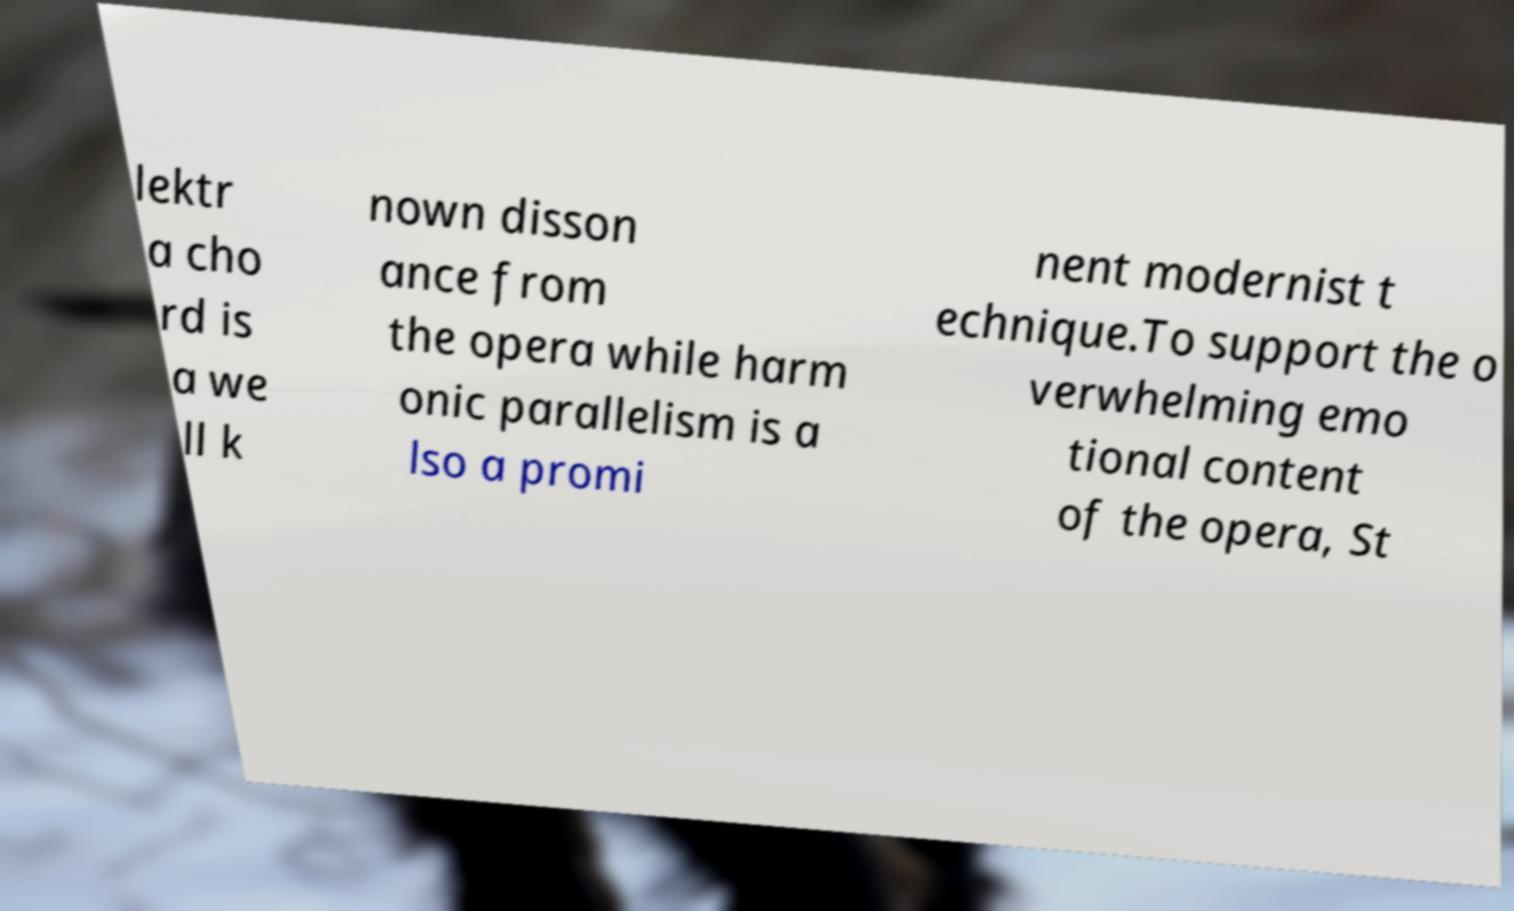Could you extract and type out the text from this image? lektr a cho rd is a we ll k nown disson ance from the opera while harm onic parallelism is a lso a promi nent modernist t echnique.To support the o verwhelming emo tional content of the opera, St 